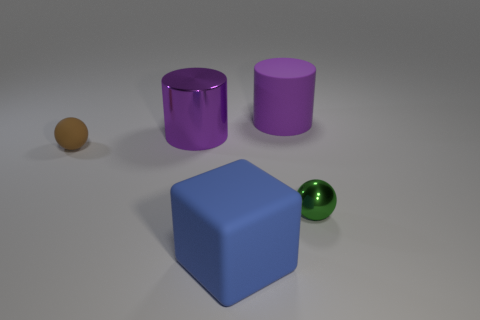There is another large cylinder that is the same color as the metal cylinder; what material is it?
Ensure brevity in your answer.  Rubber. Is the number of purple cylinders in front of the green ball less than the number of small green metal balls behind the tiny brown object?
Make the answer very short. No. What number of objects are blue things or rubber blocks to the right of the brown thing?
Offer a terse response. 1. There is a brown sphere that is the same size as the green ball; what is it made of?
Ensure brevity in your answer.  Rubber. Is the material of the brown ball the same as the blue object?
Your answer should be very brief. Yes. What is the color of the rubber object that is both behind the shiny sphere and right of the tiny rubber ball?
Provide a succinct answer. Purple. There is a matte object that is on the left side of the big blue matte cube; is its color the same as the cube?
Provide a succinct answer. No. There is a object that is the same size as the matte sphere; what shape is it?
Provide a succinct answer. Sphere. How many other things are the same color as the matte cylinder?
Keep it short and to the point. 1. What number of other objects are the same material as the small brown object?
Your response must be concise. 2. 